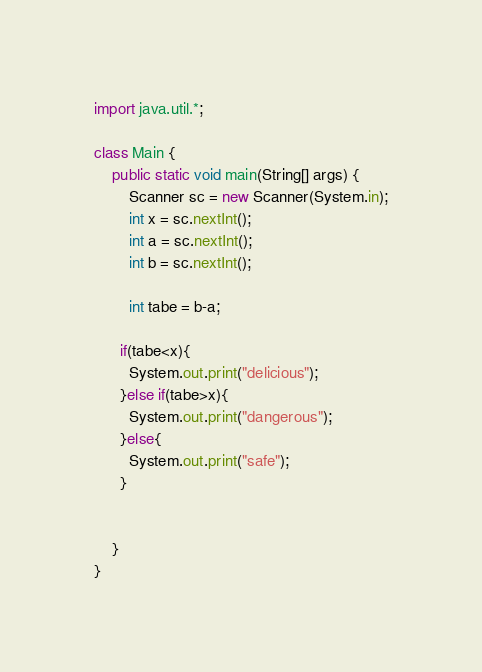Convert code to text. <code><loc_0><loc_0><loc_500><loc_500><_Java_>import java.util.*;
 
class Main {
    public static void main(String[] args) {
        Scanner sc = new Scanner(System.in);
        int x = sc.nextInt();
        int a = sc.nextInt();
        int b = sc.nextInt();
       
        int tabe = b-a;
      
      if(tabe<x){
        System.out.print("delicious");
      }else if(tabe>x){
        System.out.print("dangerous");
      }else{
        System.out.print("safe");
      }
      

    }
}</code> 